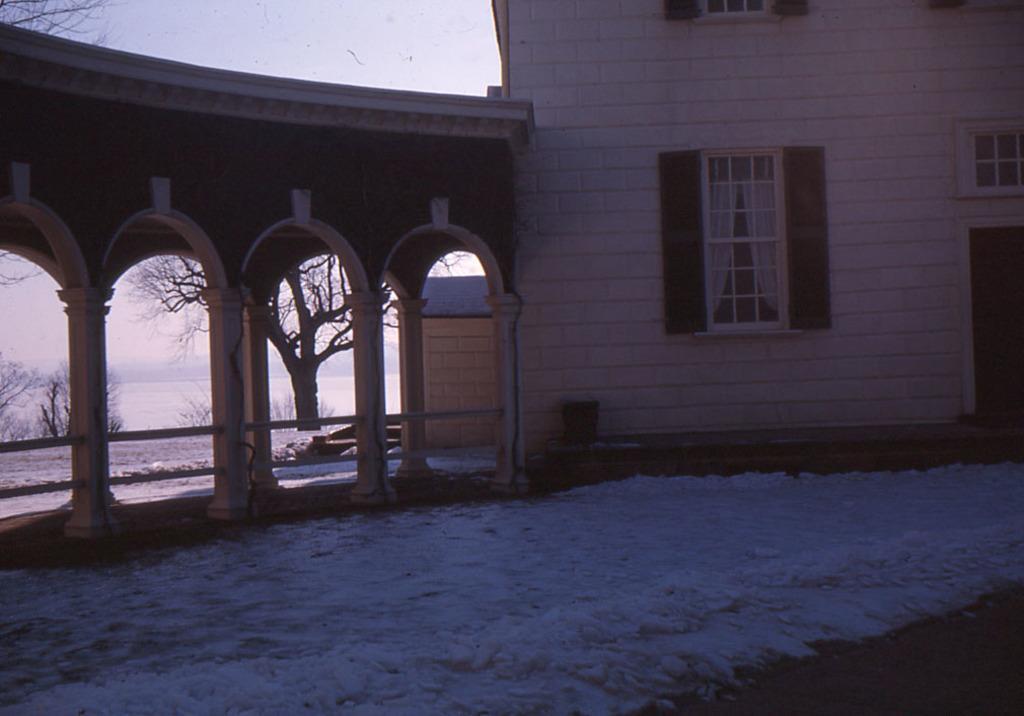In one or two sentences, can you explain what this image depicts? In this image I can see the buildings with windows and the pillars. In the background I can see the trees, water and the sky. 